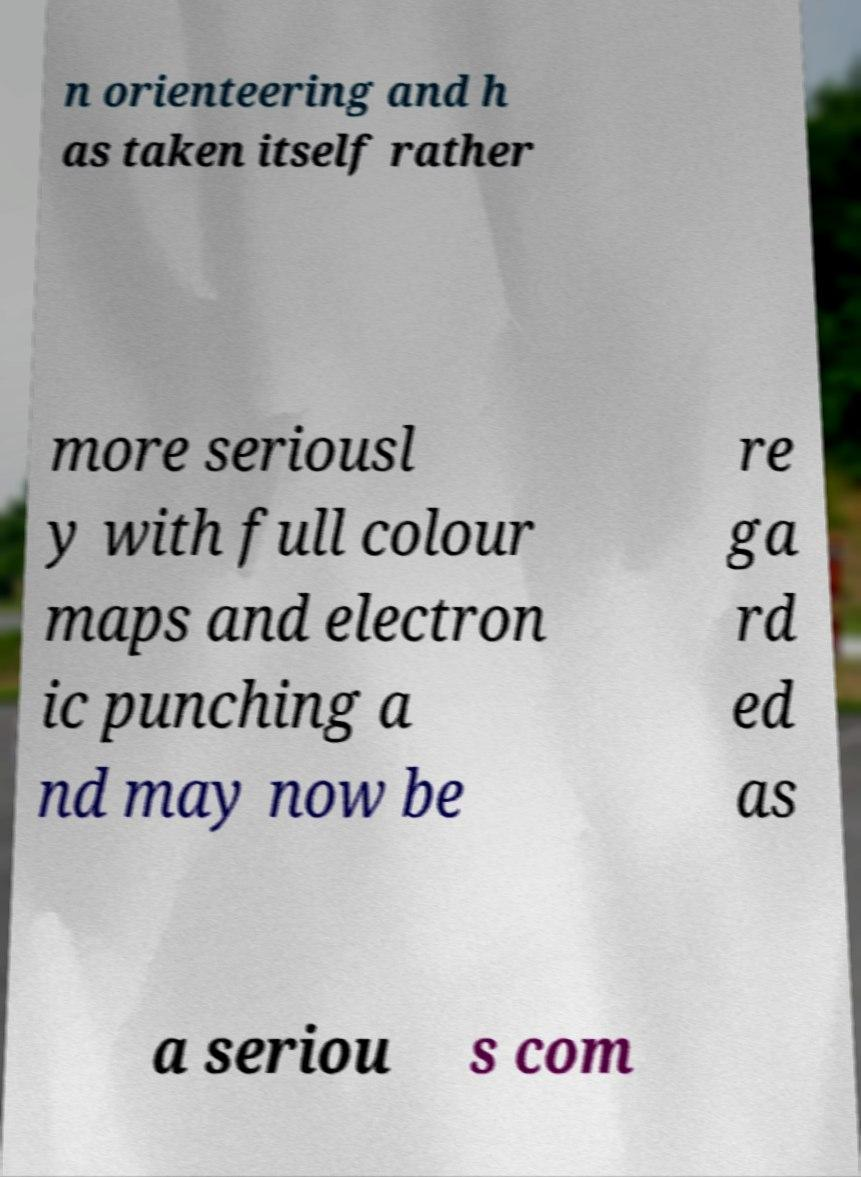Could you extract and type out the text from this image? n orienteering and h as taken itself rather more seriousl y with full colour maps and electron ic punching a nd may now be re ga rd ed as a seriou s com 